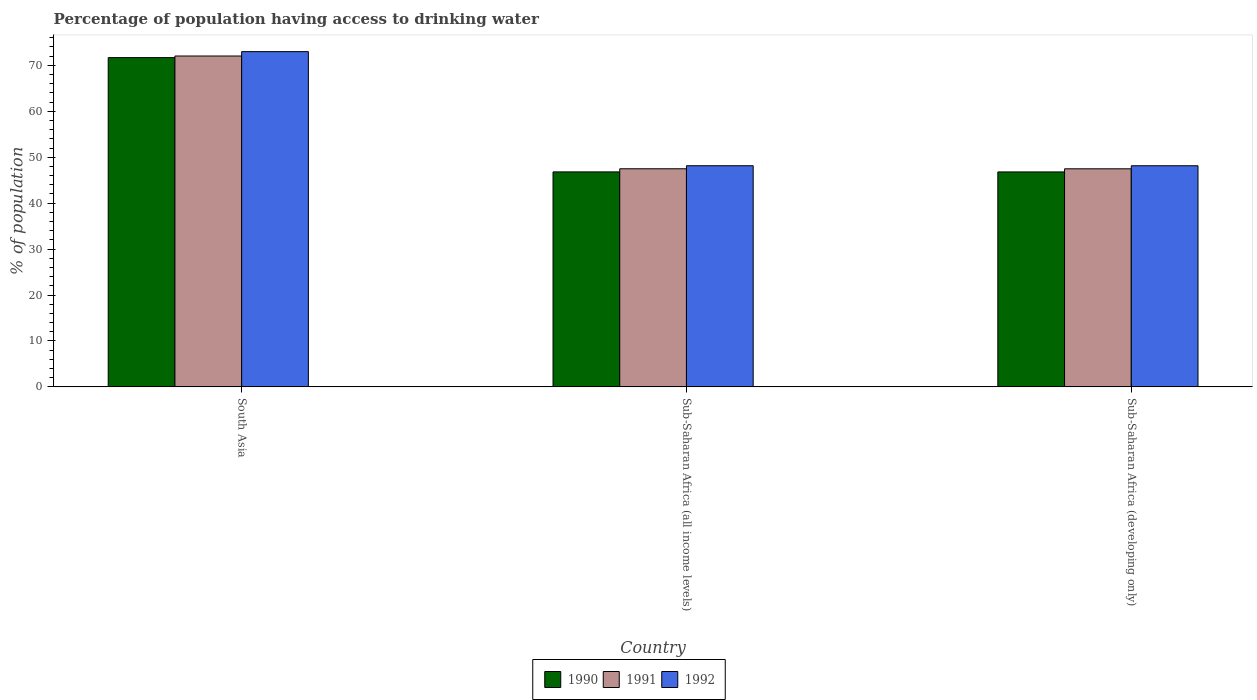How many groups of bars are there?
Give a very brief answer. 3. Are the number of bars on each tick of the X-axis equal?
Offer a terse response. Yes. How many bars are there on the 1st tick from the left?
Offer a very short reply. 3. How many bars are there on the 1st tick from the right?
Give a very brief answer. 3. What is the label of the 2nd group of bars from the left?
Offer a terse response. Sub-Saharan Africa (all income levels). What is the percentage of population having access to drinking water in 1992 in Sub-Saharan Africa (all income levels)?
Your answer should be very brief. 48.15. Across all countries, what is the maximum percentage of population having access to drinking water in 1991?
Your response must be concise. 72.03. Across all countries, what is the minimum percentage of population having access to drinking water in 1990?
Give a very brief answer. 46.8. In which country was the percentage of population having access to drinking water in 1991 maximum?
Give a very brief answer. South Asia. In which country was the percentage of population having access to drinking water in 1990 minimum?
Give a very brief answer. Sub-Saharan Africa (developing only). What is the total percentage of population having access to drinking water in 1991 in the graph?
Provide a short and direct response. 167. What is the difference between the percentage of population having access to drinking water in 1991 in South Asia and that in Sub-Saharan Africa (all income levels)?
Ensure brevity in your answer.  24.55. What is the difference between the percentage of population having access to drinking water in 1991 in Sub-Saharan Africa (developing only) and the percentage of population having access to drinking water in 1992 in South Asia?
Your answer should be very brief. -25.51. What is the average percentage of population having access to drinking water in 1990 per country?
Provide a succinct answer. 55.09. What is the difference between the percentage of population having access to drinking water of/in 1990 and percentage of population having access to drinking water of/in 1991 in Sub-Saharan Africa (all income levels)?
Provide a short and direct response. -0.68. What is the ratio of the percentage of population having access to drinking water in 1991 in Sub-Saharan Africa (all income levels) to that in Sub-Saharan Africa (developing only)?
Your answer should be compact. 1. Is the difference between the percentage of population having access to drinking water in 1990 in South Asia and Sub-Saharan Africa (all income levels) greater than the difference between the percentage of population having access to drinking water in 1991 in South Asia and Sub-Saharan Africa (all income levels)?
Offer a terse response. Yes. What is the difference between the highest and the second highest percentage of population having access to drinking water in 1990?
Your answer should be compact. -0.01. What is the difference between the highest and the lowest percentage of population having access to drinking water in 1990?
Offer a very short reply. 24.89. What does the 1st bar from the right in Sub-Saharan Africa (developing only) represents?
Make the answer very short. 1992. Is it the case that in every country, the sum of the percentage of population having access to drinking water in 1990 and percentage of population having access to drinking water in 1992 is greater than the percentage of population having access to drinking water in 1991?
Make the answer very short. Yes. Are all the bars in the graph horizontal?
Keep it short and to the point. No. What is the difference between two consecutive major ticks on the Y-axis?
Make the answer very short. 10. Are the values on the major ticks of Y-axis written in scientific E-notation?
Your answer should be compact. No. Does the graph contain grids?
Give a very brief answer. No. Where does the legend appear in the graph?
Provide a short and direct response. Bottom center. How are the legend labels stacked?
Offer a very short reply. Horizontal. What is the title of the graph?
Give a very brief answer. Percentage of population having access to drinking water. What is the label or title of the Y-axis?
Give a very brief answer. % of population. What is the % of population in 1990 in South Asia?
Make the answer very short. 71.69. What is the % of population of 1991 in South Asia?
Ensure brevity in your answer.  72.03. What is the % of population of 1992 in South Asia?
Offer a very short reply. 72.99. What is the % of population in 1990 in Sub-Saharan Africa (all income levels)?
Offer a very short reply. 46.8. What is the % of population of 1991 in Sub-Saharan Africa (all income levels)?
Your answer should be compact. 47.48. What is the % of population of 1992 in Sub-Saharan Africa (all income levels)?
Offer a terse response. 48.15. What is the % of population of 1990 in Sub-Saharan Africa (developing only)?
Provide a succinct answer. 46.8. What is the % of population in 1991 in Sub-Saharan Africa (developing only)?
Offer a terse response. 47.48. What is the % of population of 1992 in Sub-Saharan Africa (developing only)?
Provide a succinct answer. 48.14. Across all countries, what is the maximum % of population of 1990?
Provide a succinct answer. 71.69. Across all countries, what is the maximum % of population in 1991?
Your answer should be compact. 72.03. Across all countries, what is the maximum % of population in 1992?
Your response must be concise. 72.99. Across all countries, what is the minimum % of population of 1990?
Give a very brief answer. 46.8. Across all countries, what is the minimum % of population of 1991?
Offer a very short reply. 47.48. Across all countries, what is the minimum % of population of 1992?
Keep it short and to the point. 48.14. What is the total % of population of 1990 in the graph?
Keep it short and to the point. 165.28. What is the total % of population in 1991 in the graph?
Offer a very short reply. 167. What is the total % of population of 1992 in the graph?
Your response must be concise. 169.27. What is the difference between the % of population in 1990 in South Asia and that in Sub-Saharan Africa (all income levels)?
Your answer should be very brief. 24.88. What is the difference between the % of population in 1991 in South Asia and that in Sub-Saharan Africa (all income levels)?
Make the answer very short. 24.55. What is the difference between the % of population in 1992 in South Asia and that in Sub-Saharan Africa (all income levels)?
Ensure brevity in your answer.  24.84. What is the difference between the % of population of 1990 in South Asia and that in Sub-Saharan Africa (developing only)?
Offer a terse response. 24.89. What is the difference between the % of population of 1991 in South Asia and that in Sub-Saharan Africa (developing only)?
Your response must be concise. 24.56. What is the difference between the % of population in 1992 in South Asia and that in Sub-Saharan Africa (developing only)?
Offer a very short reply. 24.85. What is the difference between the % of population in 1990 in Sub-Saharan Africa (all income levels) and that in Sub-Saharan Africa (developing only)?
Your response must be concise. 0.01. What is the difference between the % of population in 1991 in Sub-Saharan Africa (all income levels) and that in Sub-Saharan Africa (developing only)?
Ensure brevity in your answer.  0.01. What is the difference between the % of population of 1992 in Sub-Saharan Africa (all income levels) and that in Sub-Saharan Africa (developing only)?
Offer a terse response. 0.01. What is the difference between the % of population of 1990 in South Asia and the % of population of 1991 in Sub-Saharan Africa (all income levels)?
Make the answer very short. 24.2. What is the difference between the % of population of 1990 in South Asia and the % of population of 1992 in Sub-Saharan Africa (all income levels)?
Your response must be concise. 23.54. What is the difference between the % of population in 1991 in South Asia and the % of population in 1992 in Sub-Saharan Africa (all income levels)?
Keep it short and to the point. 23.89. What is the difference between the % of population in 1990 in South Asia and the % of population in 1991 in Sub-Saharan Africa (developing only)?
Offer a terse response. 24.21. What is the difference between the % of population of 1990 in South Asia and the % of population of 1992 in Sub-Saharan Africa (developing only)?
Ensure brevity in your answer.  23.54. What is the difference between the % of population of 1991 in South Asia and the % of population of 1992 in Sub-Saharan Africa (developing only)?
Your response must be concise. 23.89. What is the difference between the % of population in 1990 in Sub-Saharan Africa (all income levels) and the % of population in 1991 in Sub-Saharan Africa (developing only)?
Your answer should be very brief. -0.67. What is the difference between the % of population in 1990 in Sub-Saharan Africa (all income levels) and the % of population in 1992 in Sub-Saharan Africa (developing only)?
Your answer should be compact. -1.34. What is the difference between the % of population of 1991 in Sub-Saharan Africa (all income levels) and the % of population of 1992 in Sub-Saharan Africa (developing only)?
Offer a very short reply. -0.66. What is the average % of population in 1990 per country?
Make the answer very short. 55.09. What is the average % of population of 1991 per country?
Your answer should be compact. 55.66. What is the average % of population in 1992 per country?
Your response must be concise. 56.42. What is the difference between the % of population in 1990 and % of population in 1991 in South Asia?
Your answer should be very brief. -0.35. What is the difference between the % of population in 1990 and % of population in 1992 in South Asia?
Give a very brief answer. -1.3. What is the difference between the % of population of 1991 and % of population of 1992 in South Asia?
Your response must be concise. -0.95. What is the difference between the % of population in 1990 and % of population in 1991 in Sub-Saharan Africa (all income levels)?
Keep it short and to the point. -0.68. What is the difference between the % of population in 1990 and % of population in 1992 in Sub-Saharan Africa (all income levels)?
Your answer should be compact. -1.34. What is the difference between the % of population in 1991 and % of population in 1992 in Sub-Saharan Africa (all income levels)?
Ensure brevity in your answer.  -0.66. What is the difference between the % of population in 1990 and % of population in 1991 in Sub-Saharan Africa (developing only)?
Make the answer very short. -0.68. What is the difference between the % of population in 1990 and % of population in 1992 in Sub-Saharan Africa (developing only)?
Your answer should be compact. -1.34. What is the difference between the % of population in 1991 and % of population in 1992 in Sub-Saharan Africa (developing only)?
Keep it short and to the point. -0.66. What is the ratio of the % of population in 1990 in South Asia to that in Sub-Saharan Africa (all income levels)?
Ensure brevity in your answer.  1.53. What is the ratio of the % of population of 1991 in South Asia to that in Sub-Saharan Africa (all income levels)?
Give a very brief answer. 1.52. What is the ratio of the % of population in 1992 in South Asia to that in Sub-Saharan Africa (all income levels)?
Your response must be concise. 1.52. What is the ratio of the % of population in 1990 in South Asia to that in Sub-Saharan Africa (developing only)?
Offer a terse response. 1.53. What is the ratio of the % of population in 1991 in South Asia to that in Sub-Saharan Africa (developing only)?
Your answer should be very brief. 1.52. What is the ratio of the % of population in 1992 in South Asia to that in Sub-Saharan Africa (developing only)?
Give a very brief answer. 1.52. What is the ratio of the % of population in 1990 in Sub-Saharan Africa (all income levels) to that in Sub-Saharan Africa (developing only)?
Your response must be concise. 1. What is the ratio of the % of population in 1991 in Sub-Saharan Africa (all income levels) to that in Sub-Saharan Africa (developing only)?
Offer a very short reply. 1. What is the ratio of the % of population of 1992 in Sub-Saharan Africa (all income levels) to that in Sub-Saharan Africa (developing only)?
Give a very brief answer. 1. What is the difference between the highest and the second highest % of population of 1990?
Your answer should be compact. 24.88. What is the difference between the highest and the second highest % of population of 1991?
Your response must be concise. 24.55. What is the difference between the highest and the second highest % of population of 1992?
Ensure brevity in your answer.  24.84. What is the difference between the highest and the lowest % of population of 1990?
Ensure brevity in your answer.  24.89. What is the difference between the highest and the lowest % of population in 1991?
Offer a terse response. 24.56. What is the difference between the highest and the lowest % of population in 1992?
Offer a terse response. 24.85. 